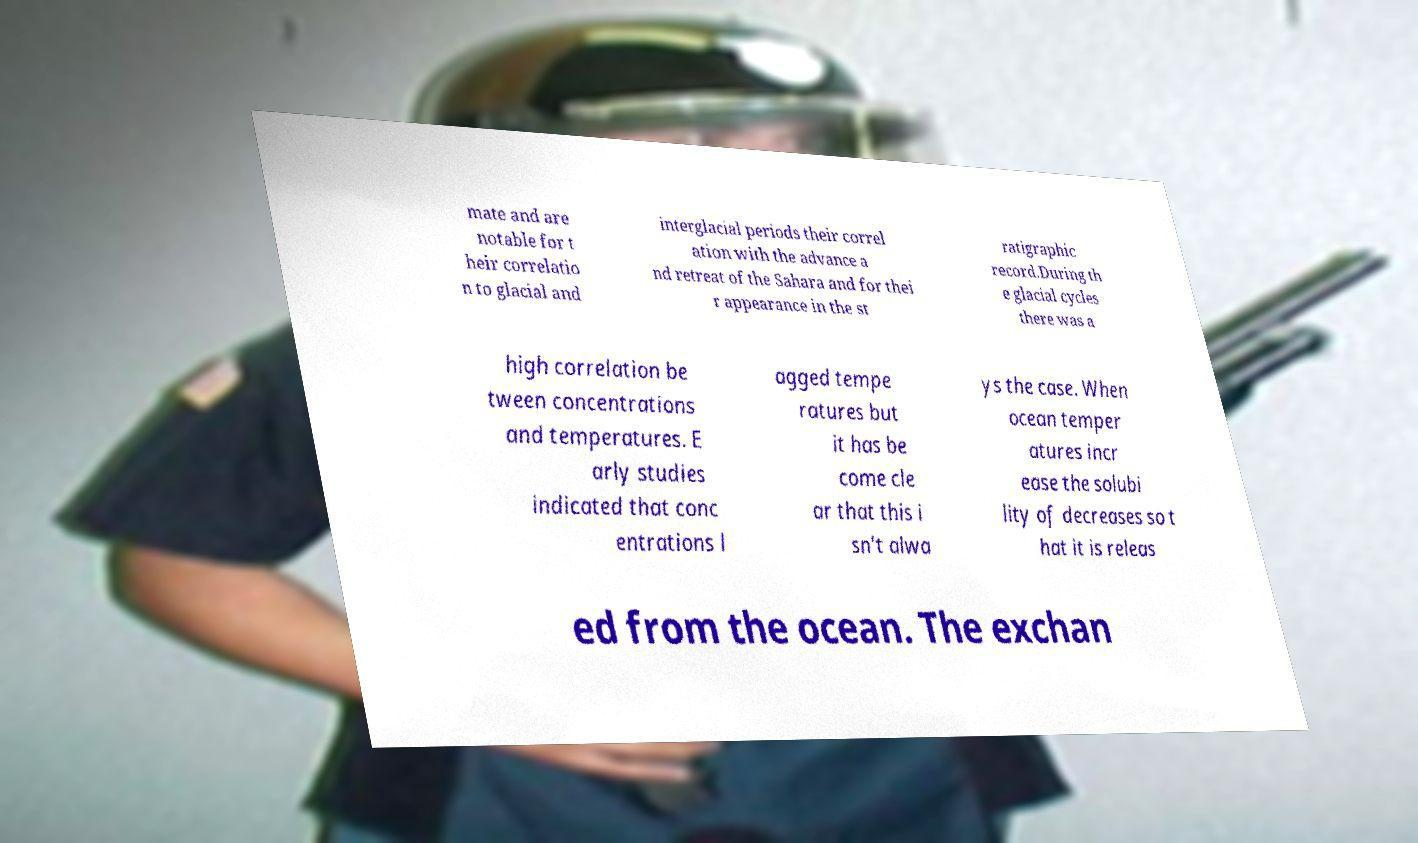Could you assist in decoding the text presented in this image and type it out clearly? mate and are notable for t heir correlatio n to glacial and interglacial periods their correl ation with the advance a nd retreat of the Sahara and for thei r appearance in the st ratigraphic record.During th e glacial cycles there was a high correlation be tween concentrations and temperatures. E arly studies indicated that conc entrations l agged tempe ratures but it has be come cle ar that this i sn't alwa ys the case. When ocean temper atures incr ease the solubi lity of decreases so t hat it is releas ed from the ocean. The exchan 